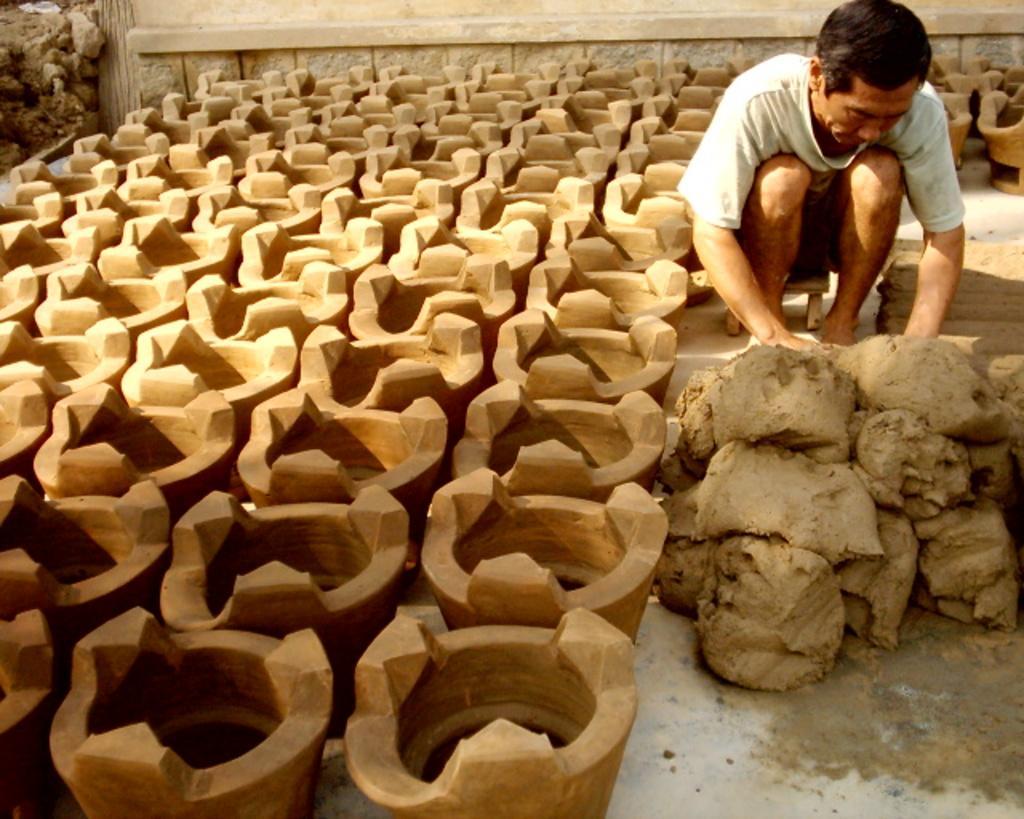Describe this image in one or two sentences. In this image we can see so many pots and there is a person sitting on the stool, in front of him we can see the clay and in the background we can see the wall. 